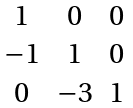<formula> <loc_0><loc_0><loc_500><loc_500>\begin{array} { c c c } 1 & 0 & 0 \\ - 1 & 1 & 0 \\ 0 & - 3 & 1 \end{array}</formula> 